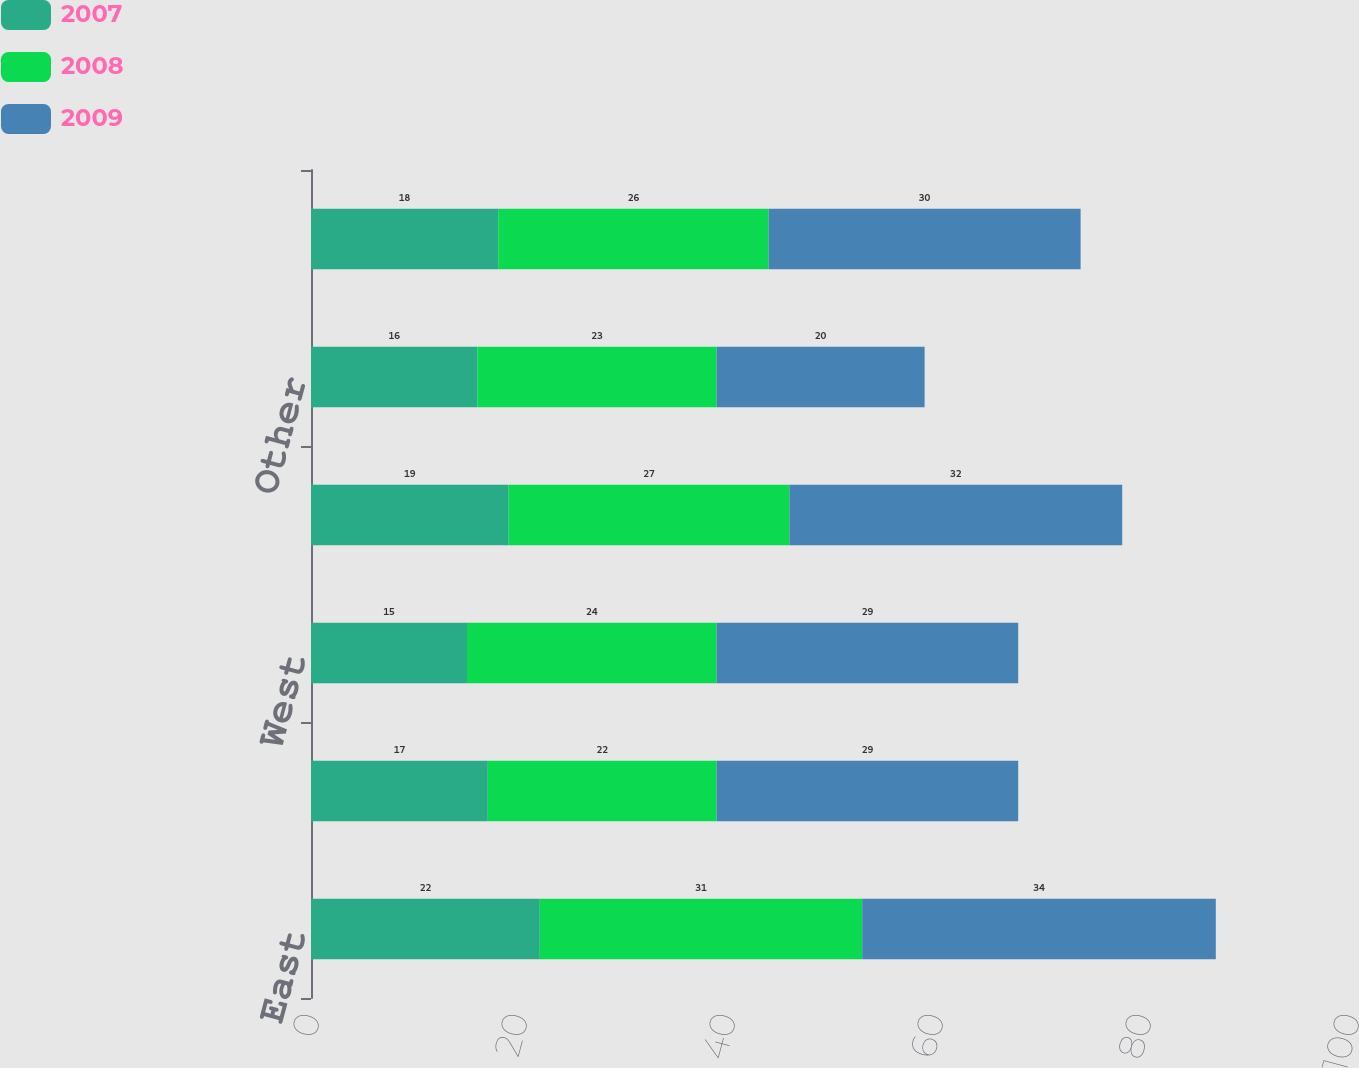Convert chart. <chart><loc_0><loc_0><loc_500><loc_500><stacked_bar_chart><ecel><fcel>East<fcel>Central<fcel>West<fcel>Houston<fcel>Other<fcel>Total<nl><fcel>2007<fcel>22<fcel>17<fcel>15<fcel>19<fcel>16<fcel>18<nl><fcel>2008<fcel>31<fcel>22<fcel>24<fcel>27<fcel>23<fcel>26<nl><fcel>2009<fcel>34<fcel>29<fcel>29<fcel>32<fcel>20<fcel>30<nl></chart> 